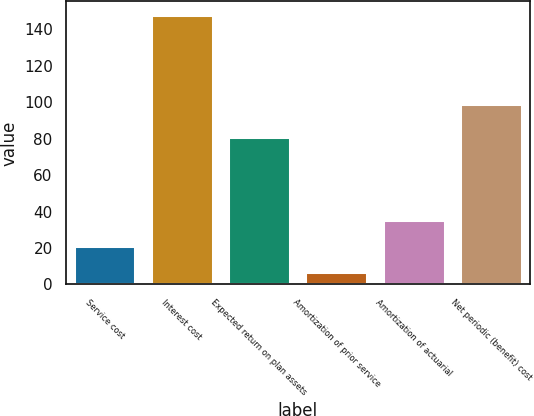Convert chart to OTSL. <chart><loc_0><loc_0><loc_500><loc_500><bar_chart><fcel>Service cost<fcel>Interest cost<fcel>Expected return on plan assets<fcel>Amortization of prior service<fcel>Amortization of actuarial<fcel>Net periodic (benefit) cost<nl><fcel>21.1<fcel>148<fcel>81<fcel>7<fcel>35.2<fcel>99<nl></chart> 